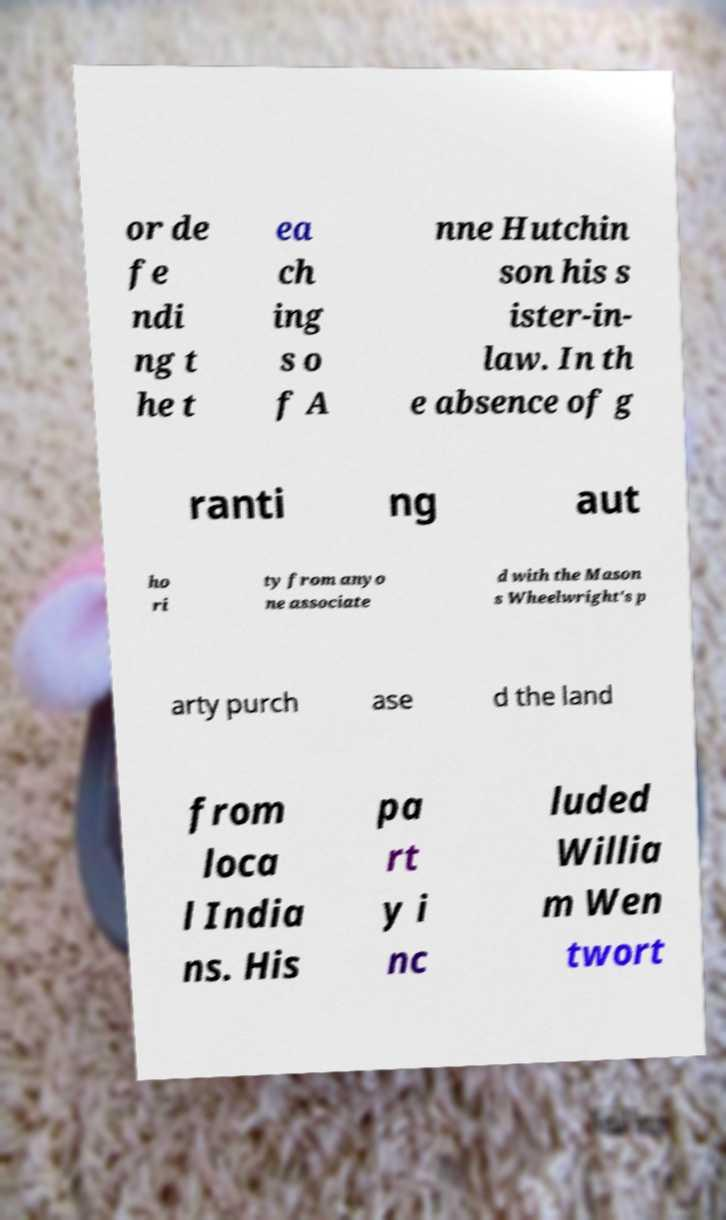There's text embedded in this image that I need extracted. Can you transcribe it verbatim? or de fe ndi ng t he t ea ch ing s o f A nne Hutchin son his s ister-in- law. In th e absence of g ranti ng aut ho ri ty from anyo ne associate d with the Mason s Wheelwright's p arty purch ase d the land from loca l India ns. His pa rt y i nc luded Willia m Wen twort 